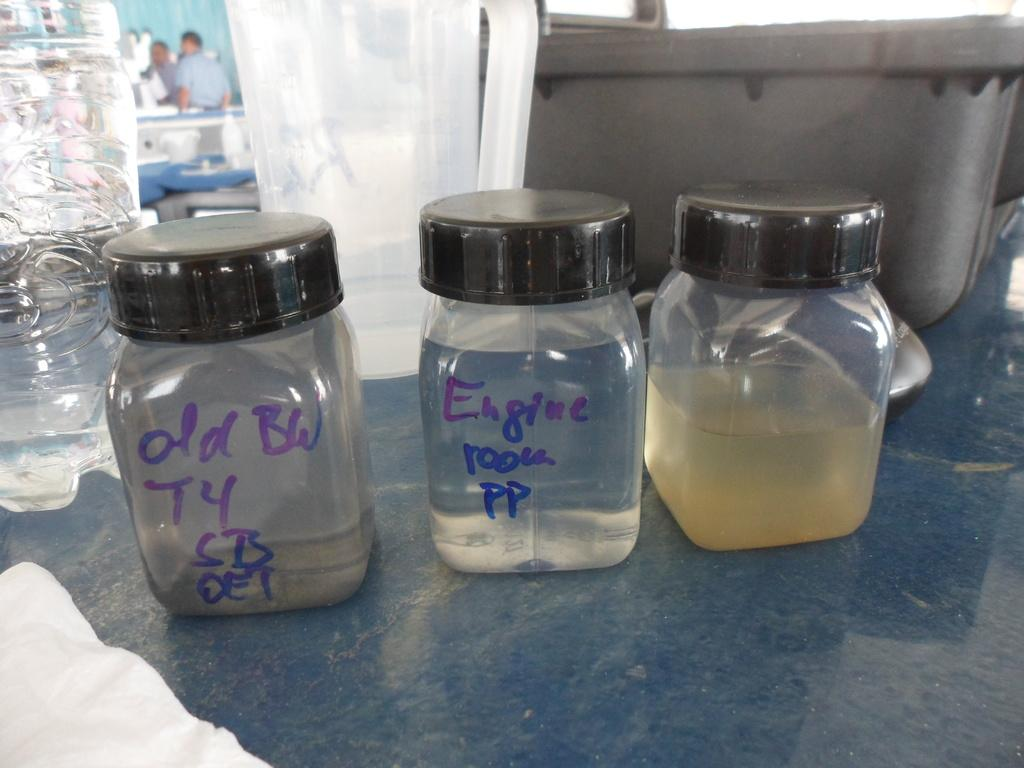<image>
Write a terse but informative summary of the picture. One of the jars is labeled engine room PP 